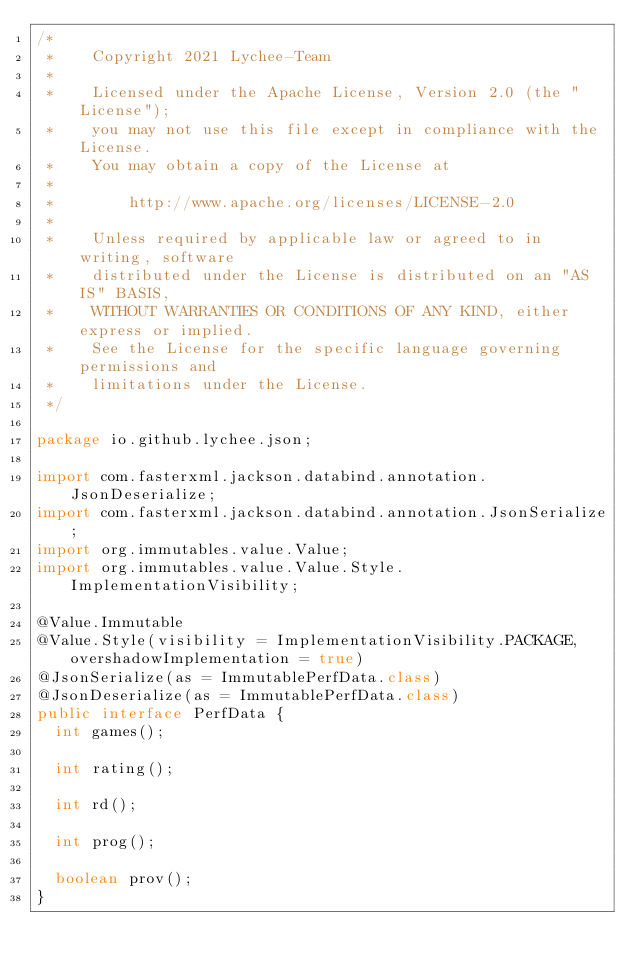<code> <loc_0><loc_0><loc_500><loc_500><_Java_>/*
 *    Copyright 2021 Lychee-Team
 *
 *    Licensed under the Apache License, Version 2.0 (the "License");
 *    you may not use this file except in compliance with the License.
 *    You may obtain a copy of the License at
 *
 *        http://www.apache.org/licenses/LICENSE-2.0
 *
 *    Unless required by applicable law or agreed to in writing, software
 *    distributed under the License is distributed on an "AS IS" BASIS,
 *    WITHOUT WARRANTIES OR CONDITIONS OF ANY KIND, either express or implied.
 *    See the License for the specific language governing permissions and
 *    limitations under the License.
 */

package io.github.lychee.json;

import com.fasterxml.jackson.databind.annotation.JsonDeserialize;
import com.fasterxml.jackson.databind.annotation.JsonSerialize;
import org.immutables.value.Value;
import org.immutables.value.Value.Style.ImplementationVisibility;

@Value.Immutable
@Value.Style(visibility = ImplementationVisibility.PACKAGE, overshadowImplementation = true)
@JsonSerialize(as = ImmutablePerfData.class)
@JsonDeserialize(as = ImmutablePerfData.class)
public interface PerfData {
	int games();

	int rating();

	int rd();

	int prog();

	boolean prov();
}
</code> 